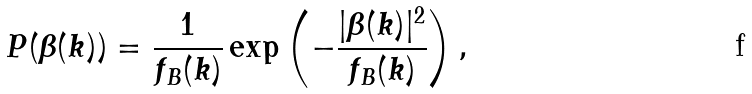<formula> <loc_0><loc_0><loc_500><loc_500>P ( \beta ( { k } ) ) = \frac { 1 } { f _ { B } ( k ) } \exp \left ( - \frac { | \beta ( { k } ) | ^ { 2 } } { f _ { B } ( k ) } \right ) ,</formula> 